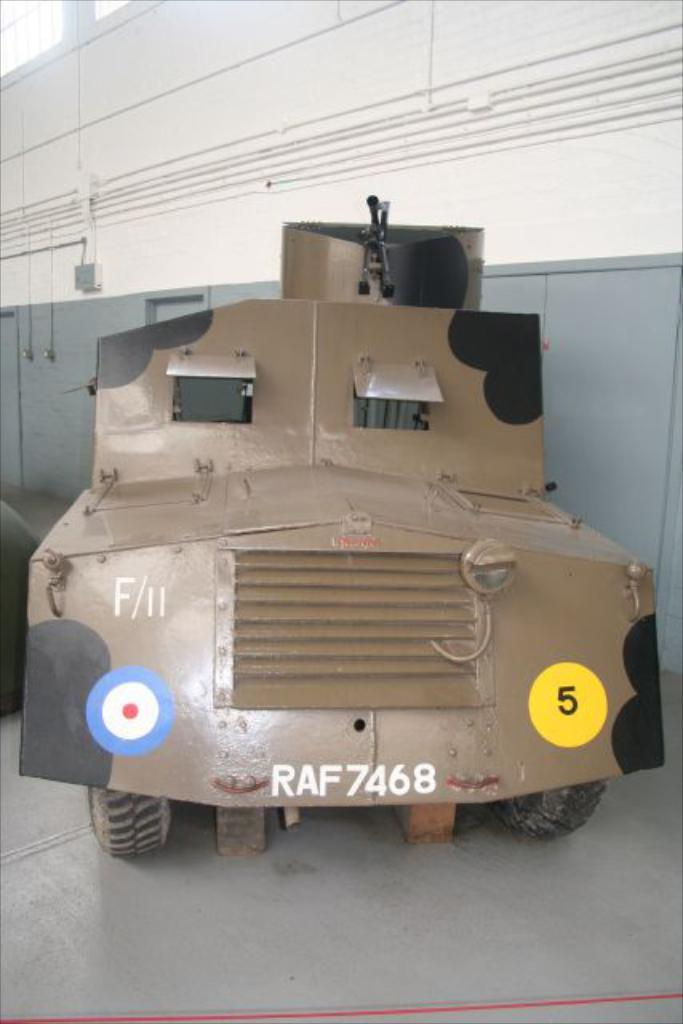What is located on the ground in the image? There is a vehicle on the ground in the image. What can be seen in the background of the image? There is a wall in the background of the image. What objects are on the wall in the background? There is a box and a grille on the wall in the background. What type of bait is being used to catch fish in the image? There is no fishing or bait present in the image; it features a vehicle, a wall, and objects on the wall. 